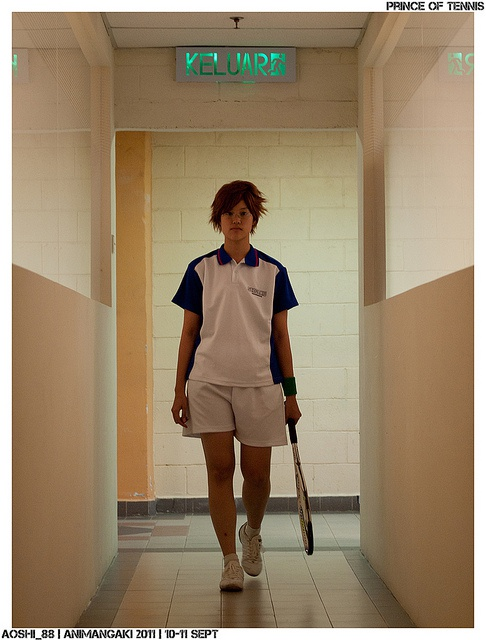Describe the objects in this image and their specific colors. I can see people in white, gray, maroon, and black tones and tennis racket in white, black, and gray tones in this image. 